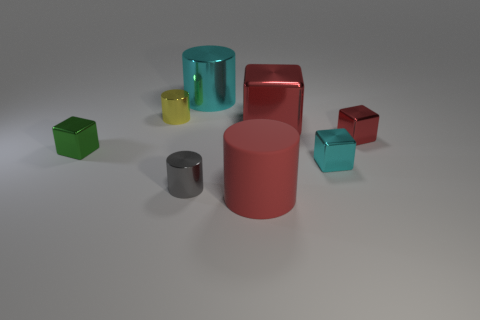Does the object in front of the gray shiny cylinder have the same size as the yellow object?
Make the answer very short. No. There is a big red cylinder; what number of yellow things are behind it?
Offer a very short reply. 1. Is there a cyan object that has the same size as the cyan shiny cylinder?
Make the answer very short. No. Do the big rubber thing and the big shiny cylinder have the same color?
Ensure brevity in your answer.  No. The small metallic cylinder that is behind the cyan metal thing that is in front of the large red shiny block is what color?
Your response must be concise. Yellow. What number of objects are left of the big shiny cylinder and in front of the yellow thing?
Offer a very short reply. 2. What number of tiny green things are the same shape as the large red shiny object?
Make the answer very short. 1. Are the yellow thing and the green thing made of the same material?
Provide a short and direct response. Yes. The cyan object on the left side of the cyan object right of the cyan shiny cylinder is what shape?
Provide a succinct answer. Cylinder. There is a cylinder on the right side of the cyan cylinder; what number of large shiny objects are behind it?
Your answer should be compact. 2. 